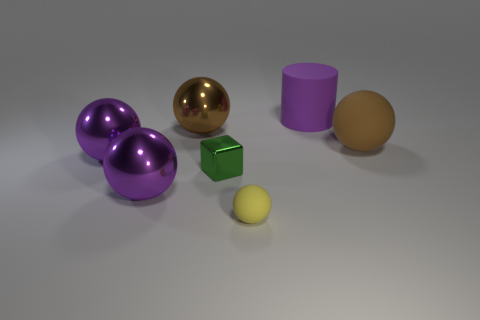Subtract all brown spheres. How many spheres are left? 3 Add 2 gray shiny cylinders. How many objects exist? 9 Subtract all purple balls. How many balls are left? 3 Subtract all spheres. How many objects are left? 2 Subtract 1 cubes. How many cubes are left? 0 Subtract all red spheres. How many brown cylinders are left? 0 Add 5 brown spheres. How many brown spheres are left? 7 Add 7 yellow matte spheres. How many yellow matte spheres exist? 8 Subtract 1 purple cylinders. How many objects are left? 6 Subtract all green balls. Subtract all purple cylinders. How many balls are left? 5 